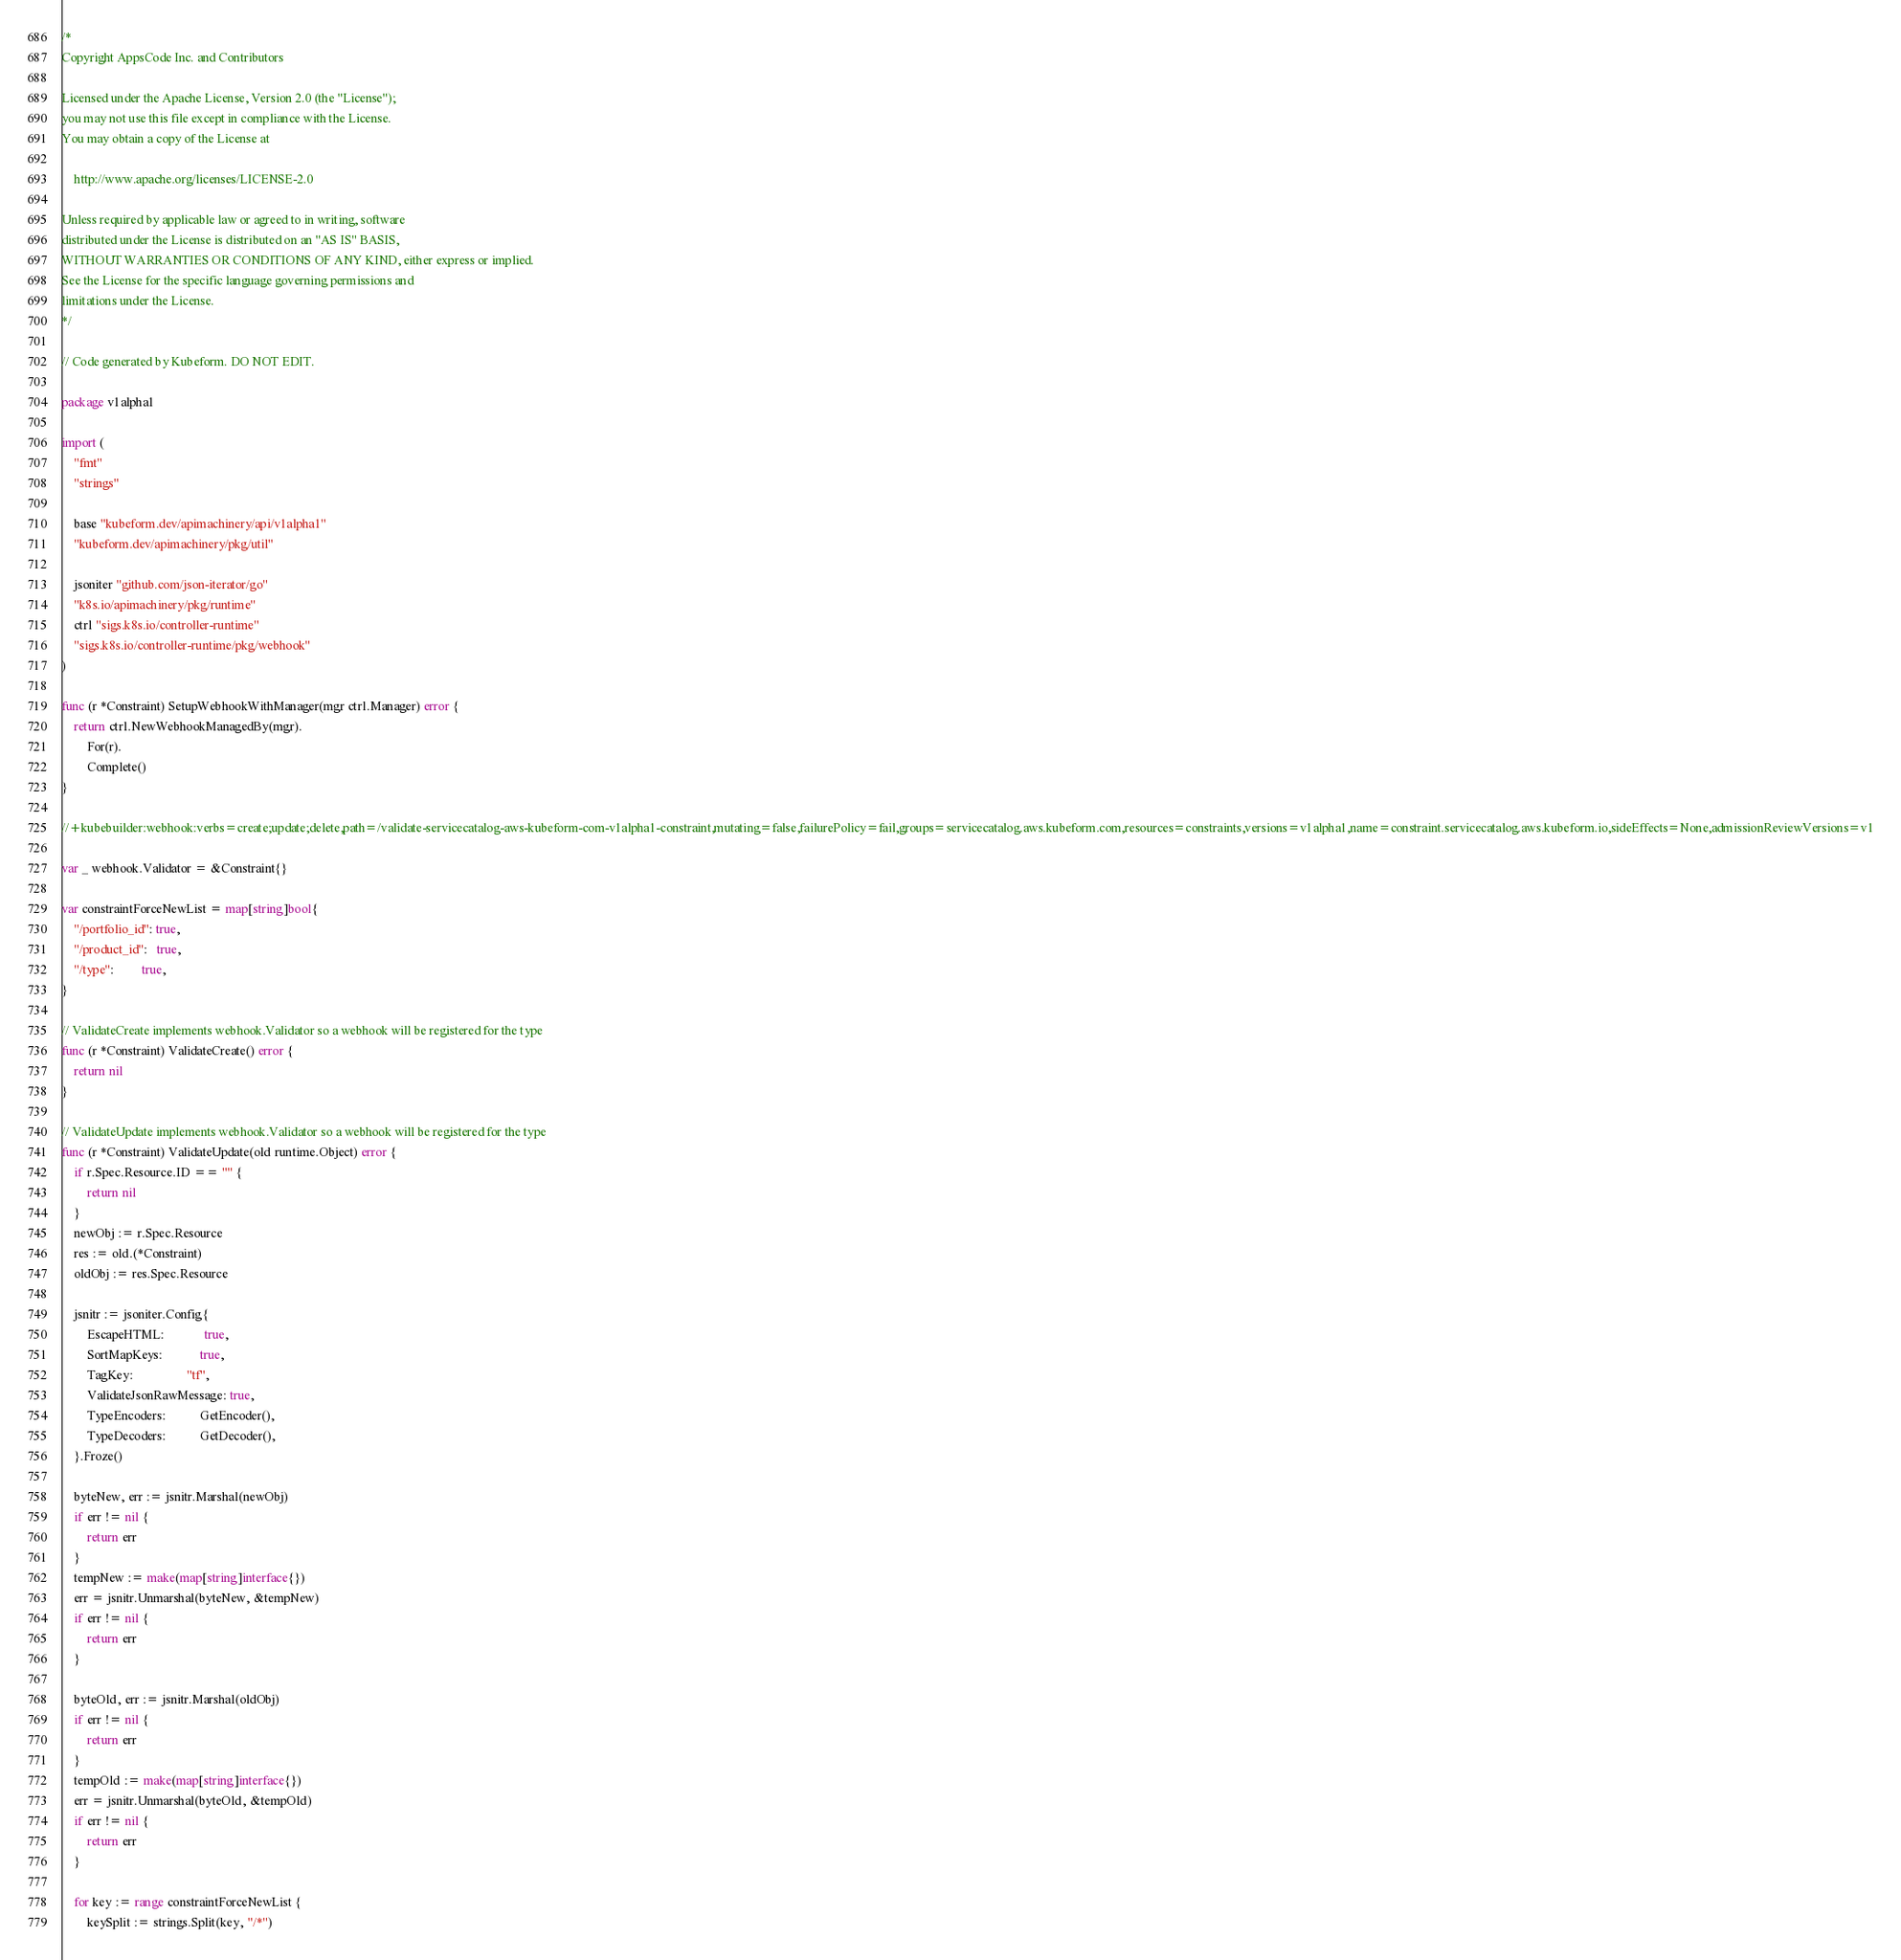<code> <loc_0><loc_0><loc_500><loc_500><_Go_>/*
Copyright AppsCode Inc. and Contributors

Licensed under the Apache License, Version 2.0 (the "License");
you may not use this file except in compliance with the License.
You may obtain a copy of the License at

    http://www.apache.org/licenses/LICENSE-2.0

Unless required by applicable law or agreed to in writing, software
distributed under the License is distributed on an "AS IS" BASIS,
WITHOUT WARRANTIES OR CONDITIONS OF ANY KIND, either express or implied.
See the License for the specific language governing permissions and
limitations under the License.
*/

// Code generated by Kubeform. DO NOT EDIT.

package v1alpha1

import (
	"fmt"
	"strings"

	base "kubeform.dev/apimachinery/api/v1alpha1"
	"kubeform.dev/apimachinery/pkg/util"

	jsoniter "github.com/json-iterator/go"
	"k8s.io/apimachinery/pkg/runtime"
	ctrl "sigs.k8s.io/controller-runtime"
	"sigs.k8s.io/controller-runtime/pkg/webhook"
)

func (r *Constraint) SetupWebhookWithManager(mgr ctrl.Manager) error {
	return ctrl.NewWebhookManagedBy(mgr).
		For(r).
		Complete()
}

//+kubebuilder:webhook:verbs=create;update;delete,path=/validate-servicecatalog-aws-kubeform-com-v1alpha1-constraint,mutating=false,failurePolicy=fail,groups=servicecatalog.aws.kubeform.com,resources=constraints,versions=v1alpha1,name=constraint.servicecatalog.aws.kubeform.io,sideEffects=None,admissionReviewVersions=v1

var _ webhook.Validator = &Constraint{}

var constraintForceNewList = map[string]bool{
	"/portfolio_id": true,
	"/product_id":   true,
	"/type":         true,
}

// ValidateCreate implements webhook.Validator so a webhook will be registered for the type
func (r *Constraint) ValidateCreate() error {
	return nil
}

// ValidateUpdate implements webhook.Validator so a webhook will be registered for the type
func (r *Constraint) ValidateUpdate(old runtime.Object) error {
	if r.Spec.Resource.ID == "" {
		return nil
	}
	newObj := r.Spec.Resource
	res := old.(*Constraint)
	oldObj := res.Spec.Resource

	jsnitr := jsoniter.Config{
		EscapeHTML:             true,
		SortMapKeys:            true,
		TagKey:                 "tf",
		ValidateJsonRawMessage: true,
		TypeEncoders:           GetEncoder(),
		TypeDecoders:           GetDecoder(),
	}.Froze()

	byteNew, err := jsnitr.Marshal(newObj)
	if err != nil {
		return err
	}
	tempNew := make(map[string]interface{})
	err = jsnitr.Unmarshal(byteNew, &tempNew)
	if err != nil {
		return err
	}

	byteOld, err := jsnitr.Marshal(oldObj)
	if err != nil {
		return err
	}
	tempOld := make(map[string]interface{})
	err = jsnitr.Unmarshal(byteOld, &tempOld)
	if err != nil {
		return err
	}

	for key := range constraintForceNewList {
		keySplit := strings.Split(key, "/*")</code> 